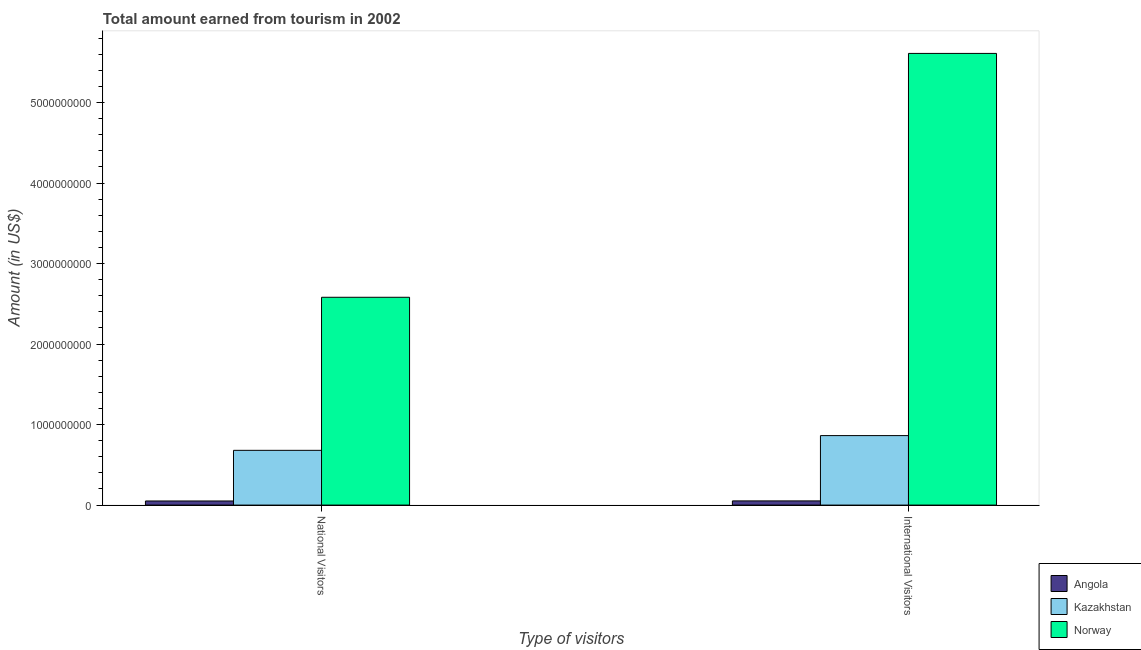How many different coloured bars are there?
Give a very brief answer. 3. How many groups of bars are there?
Offer a terse response. 2. Are the number of bars per tick equal to the number of legend labels?
Provide a succinct answer. Yes. How many bars are there on the 1st tick from the left?
Your answer should be compact. 3. What is the label of the 2nd group of bars from the left?
Your response must be concise. International Visitors. What is the amount earned from international visitors in Angola?
Your response must be concise. 5.20e+07. Across all countries, what is the maximum amount earned from international visitors?
Give a very brief answer. 5.61e+09. Across all countries, what is the minimum amount earned from national visitors?
Offer a very short reply. 5.10e+07. In which country was the amount earned from international visitors minimum?
Your response must be concise. Angola. What is the total amount earned from national visitors in the graph?
Give a very brief answer. 3.31e+09. What is the difference between the amount earned from international visitors in Norway and that in Kazakhstan?
Give a very brief answer. 4.75e+09. What is the difference between the amount earned from international visitors in Angola and the amount earned from national visitors in Kazakhstan?
Provide a succinct answer. -6.28e+08. What is the average amount earned from international visitors per country?
Offer a terse response. 2.18e+09. What is the difference between the amount earned from national visitors and amount earned from international visitors in Angola?
Give a very brief answer. -1.00e+06. What is the ratio of the amount earned from national visitors in Angola to that in Kazakhstan?
Your response must be concise. 0.07. Is the amount earned from international visitors in Angola less than that in Kazakhstan?
Keep it short and to the point. Yes. In how many countries, is the amount earned from national visitors greater than the average amount earned from national visitors taken over all countries?
Keep it short and to the point. 1. What does the 2nd bar from the left in National Visitors represents?
Your response must be concise. Kazakhstan. What does the 3rd bar from the right in International Visitors represents?
Offer a very short reply. Angola. How many countries are there in the graph?
Offer a terse response. 3. What is the difference between two consecutive major ticks on the Y-axis?
Provide a short and direct response. 1.00e+09. Are the values on the major ticks of Y-axis written in scientific E-notation?
Keep it short and to the point. No. Does the graph contain any zero values?
Offer a terse response. No. Does the graph contain grids?
Offer a very short reply. No. How many legend labels are there?
Make the answer very short. 3. What is the title of the graph?
Ensure brevity in your answer.  Total amount earned from tourism in 2002. Does "Philippines" appear as one of the legend labels in the graph?
Offer a terse response. No. What is the label or title of the X-axis?
Make the answer very short. Type of visitors. What is the Amount (in US$) of Angola in National Visitors?
Provide a succinct answer. 5.10e+07. What is the Amount (in US$) in Kazakhstan in National Visitors?
Keep it short and to the point. 6.80e+08. What is the Amount (in US$) in Norway in National Visitors?
Your response must be concise. 2.58e+09. What is the Amount (in US$) in Angola in International Visitors?
Keep it short and to the point. 5.20e+07. What is the Amount (in US$) of Kazakhstan in International Visitors?
Provide a succinct answer. 8.63e+08. What is the Amount (in US$) in Norway in International Visitors?
Provide a short and direct response. 5.61e+09. Across all Type of visitors, what is the maximum Amount (in US$) in Angola?
Your answer should be compact. 5.20e+07. Across all Type of visitors, what is the maximum Amount (in US$) in Kazakhstan?
Keep it short and to the point. 8.63e+08. Across all Type of visitors, what is the maximum Amount (in US$) of Norway?
Offer a terse response. 5.61e+09. Across all Type of visitors, what is the minimum Amount (in US$) of Angola?
Provide a succinct answer. 5.10e+07. Across all Type of visitors, what is the minimum Amount (in US$) in Kazakhstan?
Provide a short and direct response. 6.80e+08. Across all Type of visitors, what is the minimum Amount (in US$) in Norway?
Offer a very short reply. 2.58e+09. What is the total Amount (in US$) of Angola in the graph?
Provide a short and direct response. 1.03e+08. What is the total Amount (in US$) of Kazakhstan in the graph?
Provide a short and direct response. 1.54e+09. What is the total Amount (in US$) in Norway in the graph?
Your answer should be very brief. 8.19e+09. What is the difference between the Amount (in US$) in Kazakhstan in National Visitors and that in International Visitors?
Provide a succinct answer. -1.83e+08. What is the difference between the Amount (in US$) in Norway in National Visitors and that in International Visitors?
Offer a very short reply. -3.03e+09. What is the difference between the Amount (in US$) in Angola in National Visitors and the Amount (in US$) in Kazakhstan in International Visitors?
Offer a very short reply. -8.12e+08. What is the difference between the Amount (in US$) in Angola in National Visitors and the Amount (in US$) in Norway in International Visitors?
Provide a short and direct response. -5.56e+09. What is the difference between the Amount (in US$) of Kazakhstan in National Visitors and the Amount (in US$) of Norway in International Visitors?
Offer a terse response. -4.93e+09. What is the average Amount (in US$) in Angola per Type of visitors?
Offer a very short reply. 5.15e+07. What is the average Amount (in US$) of Kazakhstan per Type of visitors?
Provide a succinct answer. 7.72e+08. What is the average Amount (in US$) of Norway per Type of visitors?
Make the answer very short. 4.10e+09. What is the difference between the Amount (in US$) in Angola and Amount (in US$) in Kazakhstan in National Visitors?
Offer a very short reply. -6.29e+08. What is the difference between the Amount (in US$) of Angola and Amount (in US$) of Norway in National Visitors?
Your answer should be compact. -2.53e+09. What is the difference between the Amount (in US$) of Kazakhstan and Amount (in US$) of Norway in National Visitors?
Your answer should be very brief. -1.90e+09. What is the difference between the Amount (in US$) of Angola and Amount (in US$) of Kazakhstan in International Visitors?
Provide a short and direct response. -8.11e+08. What is the difference between the Amount (in US$) in Angola and Amount (in US$) in Norway in International Visitors?
Make the answer very short. -5.56e+09. What is the difference between the Amount (in US$) in Kazakhstan and Amount (in US$) in Norway in International Visitors?
Make the answer very short. -4.75e+09. What is the ratio of the Amount (in US$) of Angola in National Visitors to that in International Visitors?
Provide a short and direct response. 0.98. What is the ratio of the Amount (in US$) in Kazakhstan in National Visitors to that in International Visitors?
Offer a very short reply. 0.79. What is the ratio of the Amount (in US$) of Norway in National Visitors to that in International Visitors?
Offer a very short reply. 0.46. What is the difference between the highest and the second highest Amount (in US$) in Angola?
Provide a succinct answer. 1.00e+06. What is the difference between the highest and the second highest Amount (in US$) of Kazakhstan?
Keep it short and to the point. 1.83e+08. What is the difference between the highest and the second highest Amount (in US$) in Norway?
Provide a short and direct response. 3.03e+09. What is the difference between the highest and the lowest Amount (in US$) in Kazakhstan?
Keep it short and to the point. 1.83e+08. What is the difference between the highest and the lowest Amount (in US$) of Norway?
Your answer should be very brief. 3.03e+09. 